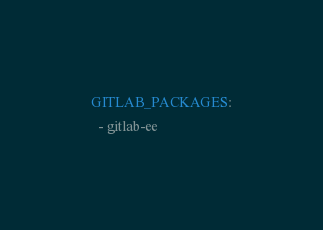Convert code to text. <code><loc_0><loc_0><loc_500><loc_500><_YAML_>GITLAB_PACKAGES:
  - gitlab-ee</code> 